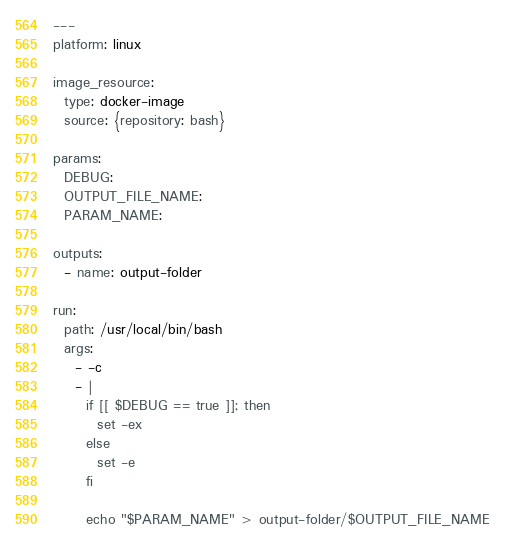Convert code to text. <code><loc_0><loc_0><loc_500><loc_500><_YAML_>---
platform: linux

image_resource:
  type: docker-image
  source: {repository: bash}

params:
  DEBUG:
  OUTPUT_FILE_NAME:
  PARAM_NAME:

outputs:
  - name: output-folder

run:
  path: /usr/local/bin/bash
  args:
    - -c
    - |
      if [[ $DEBUG == true ]]; then
        set -ex
      else
        set -e
      fi

      echo "$PARAM_NAME" > output-folder/$OUTPUT_FILE_NAME
</code> 